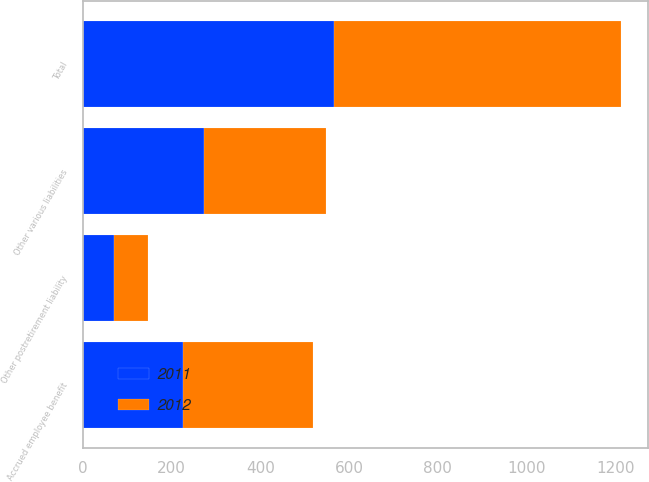<chart> <loc_0><loc_0><loc_500><loc_500><stacked_bar_chart><ecel><fcel>Accrued employee benefit<fcel>Other postretirement liability<fcel>Other various liabilities<fcel>Total<nl><fcel>2012<fcel>292.6<fcel>77.3<fcel>276.1<fcel>646<nl><fcel>2011<fcel>226.2<fcel>68.9<fcel>271.9<fcel>567<nl></chart> 